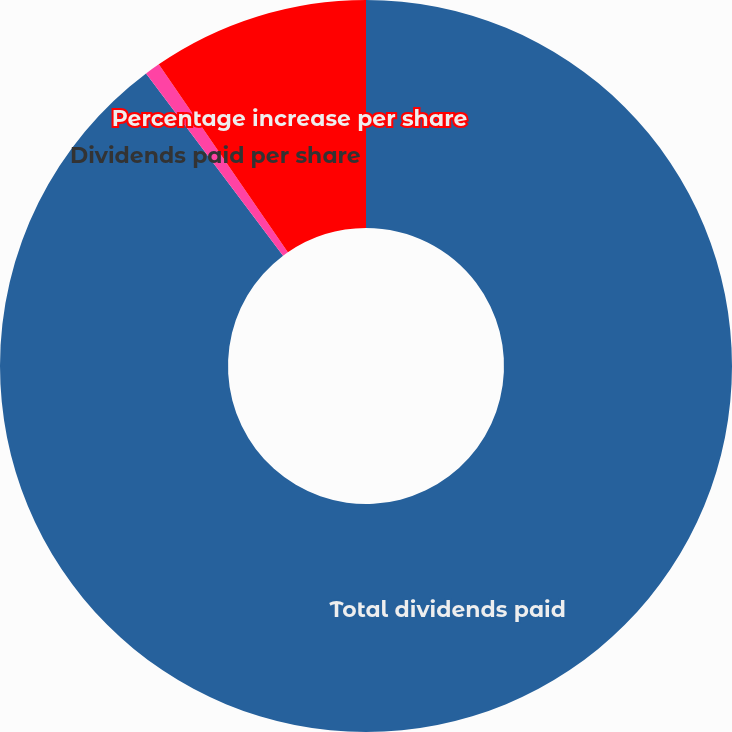<chart> <loc_0><loc_0><loc_500><loc_500><pie_chart><fcel>Total dividends paid<fcel>Dividends paid per share<fcel>Percentage increase per share<nl><fcel>89.74%<fcel>0.68%<fcel>9.58%<nl></chart> 